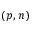<formula> <loc_0><loc_0><loc_500><loc_500>( p , n )</formula> 